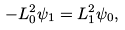Convert formula to latex. <formula><loc_0><loc_0><loc_500><loc_500>- L _ { 0 } ^ { 2 } \psi _ { 1 } = L _ { 1 } ^ { 2 } \psi _ { 0 } ,</formula> 